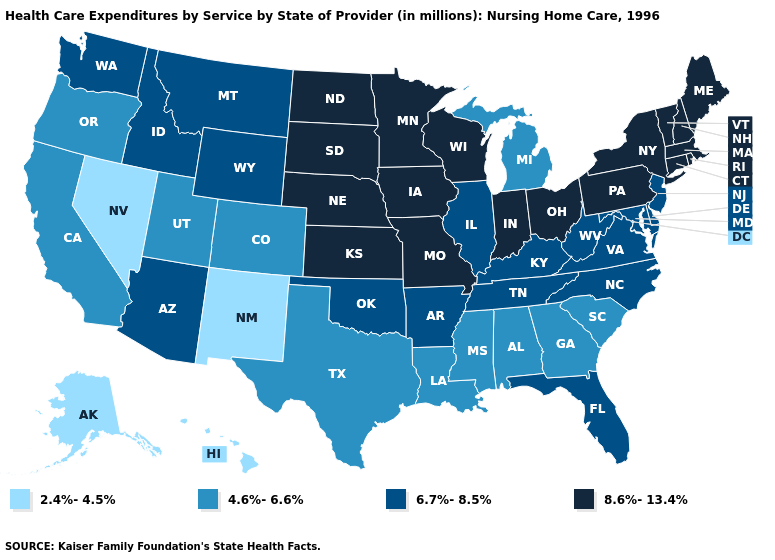Does Maine have the lowest value in the Northeast?
Write a very short answer. No. Name the states that have a value in the range 2.4%-4.5%?
Concise answer only. Alaska, Hawaii, Nevada, New Mexico. What is the value of Tennessee?
Write a very short answer. 6.7%-8.5%. Name the states that have a value in the range 2.4%-4.5%?
Be succinct. Alaska, Hawaii, Nevada, New Mexico. Which states hav the highest value in the West?
Write a very short answer. Arizona, Idaho, Montana, Washington, Wyoming. Does Tennessee have the lowest value in the South?
Write a very short answer. No. Name the states that have a value in the range 8.6%-13.4%?
Quick response, please. Connecticut, Indiana, Iowa, Kansas, Maine, Massachusetts, Minnesota, Missouri, Nebraska, New Hampshire, New York, North Dakota, Ohio, Pennsylvania, Rhode Island, South Dakota, Vermont, Wisconsin. Name the states that have a value in the range 2.4%-4.5%?
Write a very short answer. Alaska, Hawaii, Nevada, New Mexico. Which states have the lowest value in the West?
Answer briefly. Alaska, Hawaii, Nevada, New Mexico. Name the states that have a value in the range 6.7%-8.5%?
Give a very brief answer. Arizona, Arkansas, Delaware, Florida, Idaho, Illinois, Kentucky, Maryland, Montana, New Jersey, North Carolina, Oklahoma, Tennessee, Virginia, Washington, West Virginia, Wyoming. Does Rhode Island have a higher value than West Virginia?
Answer briefly. Yes. Does Kansas have the highest value in the USA?
Write a very short answer. Yes. Name the states that have a value in the range 2.4%-4.5%?
Short answer required. Alaska, Hawaii, Nevada, New Mexico. Name the states that have a value in the range 4.6%-6.6%?
Quick response, please. Alabama, California, Colorado, Georgia, Louisiana, Michigan, Mississippi, Oregon, South Carolina, Texas, Utah. What is the value of Virginia?
Give a very brief answer. 6.7%-8.5%. 